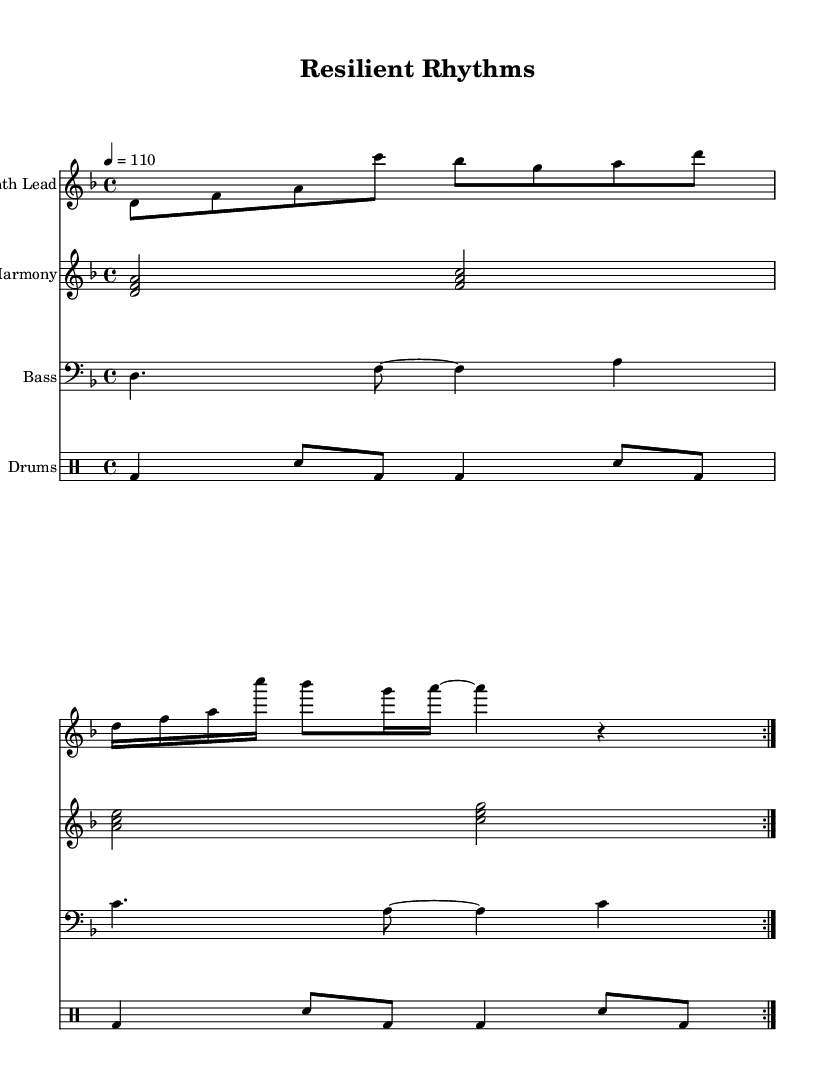What is the key signature of this music? The key signature indicates that the piece is in D minor, which has one flat (B♭). This can be checked by looking at the key signature at the beginning of the staff.
Answer: D minor What is the time signature of this piece? The time signature is found at the beginning of the score, showing the organization of beats in a measure. This piece has a time signature of 4/4, meaning there are four beats per measure and the quarter note gets one beat.
Answer: 4/4 What is the tempo marking for this composition? The tempo is indicated in the score and provides the speed of the music. Here, it is marked as quarter note equals 110, meaning the piece should be played at a moderate pace of 110 beats per minute.
Answer: 110 How many measures are in the melody section? By counting the measures represented in the melody part, we can find it spans across 4 measures since it repeats twice in the volta. The melody shown has two sets of measures that are identical.
Answer: 4 What instrument plays the harmony? The instrument designated for the harmony is specified at the beginning of the staff, labeled as "Harmony." It indicates that the harmony is being played on a piano staff, which typically comprises chord structures.
Answer: Piano How many different sections does the drum part contain? The drum part articulates its pattern over the two lines of music presented. The pattern shows a consistent repetition and can be classified as having a single recognizable section that repeats within the score.
Answer: 1 Is the bass line in the treble or bass clef? The bass line is notated in a different clef from the melody and harmony. It uses the bass clef, which is indicated at the beginning of the staff for the bass instrument, distinguishing it from the others.
Answer: Bass clef 